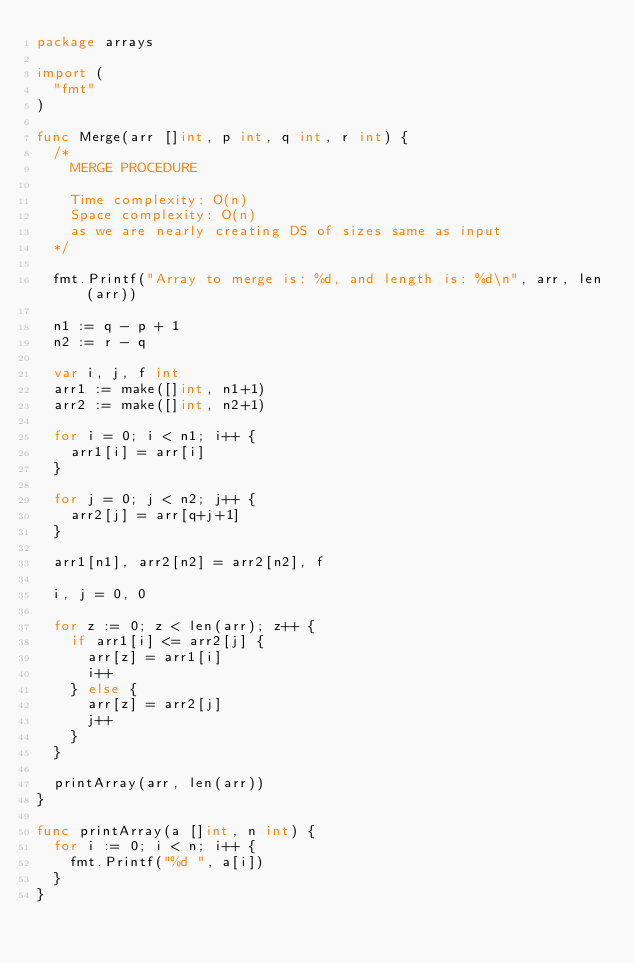<code> <loc_0><loc_0><loc_500><loc_500><_Go_>package arrays

import (
	"fmt"
)

func Merge(arr []int, p int, q int, r int) {
	/*
		MERGE PROCEDURE

		Time complexity: O(n)
		Space complexity: O(n)
		as we are nearly creating DS of sizes same as input
	*/

	fmt.Printf("Array to merge is: %d, and length is: %d\n", arr, len(arr))

	n1 := q - p + 1
	n2 := r - q

	var i, j, f int
	arr1 := make([]int, n1+1)
	arr2 := make([]int, n2+1)

	for i = 0; i < n1; i++ {
		arr1[i] = arr[i]
	}

	for j = 0; j < n2; j++ {
		arr2[j] = arr[q+j+1]
	}

	arr1[n1], arr2[n2] = arr2[n2], f

	i, j = 0, 0

	for z := 0; z < len(arr); z++ {
		if arr1[i] <= arr2[j] {
			arr[z] = arr1[i]
			i++
		} else {
			arr[z] = arr2[j]
			j++
		}
	}

	printArray(arr, len(arr))
}

func printArray(a []int, n int) {
	for i := 0; i < n; i++ {
		fmt.Printf("%d ", a[i])
	}
}
</code> 